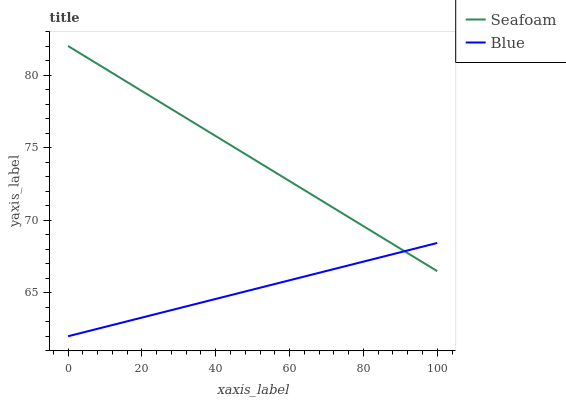Does Blue have the minimum area under the curve?
Answer yes or no. Yes. Does Seafoam have the maximum area under the curve?
Answer yes or no. Yes. Does Seafoam have the minimum area under the curve?
Answer yes or no. No. Is Blue the smoothest?
Answer yes or no. Yes. Is Seafoam the roughest?
Answer yes or no. Yes. Is Seafoam the smoothest?
Answer yes or no. No. Does Blue have the lowest value?
Answer yes or no. Yes. Does Seafoam have the lowest value?
Answer yes or no. No. Does Seafoam have the highest value?
Answer yes or no. Yes. Does Blue intersect Seafoam?
Answer yes or no. Yes. Is Blue less than Seafoam?
Answer yes or no. No. Is Blue greater than Seafoam?
Answer yes or no. No. 